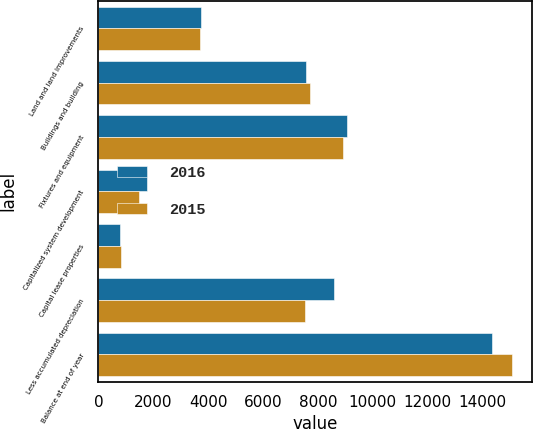<chart> <loc_0><loc_0><loc_500><loc_500><stacked_bar_chart><ecel><fcel>Land and land improvements<fcel>Buildings and building<fcel>Fixtures and equipment<fcel>Capitalized system development<fcel>Capital lease properties<fcel>Less accumulated depreciation<fcel>Balance at end of year<nl><fcel>2016<fcel>3738<fcel>7557<fcel>9064<fcel>1787<fcel>789<fcel>8600<fcel>14335<nl><fcel>2015<fcel>3687<fcel>7705<fcel>8904<fcel>1491<fcel>821<fcel>7540<fcel>15068<nl></chart> 